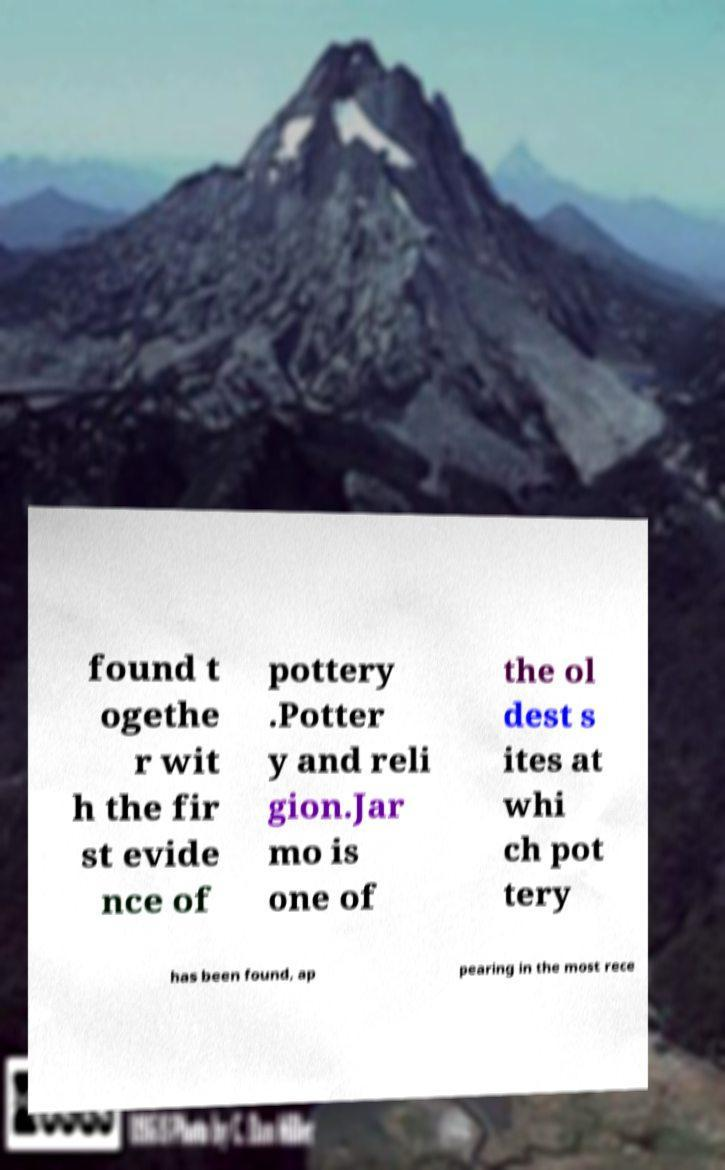What messages or text are displayed in this image? I need them in a readable, typed format. found t ogethe r wit h the fir st evide nce of pottery .Potter y and reli gion.Jar mo is one of the ol dest s ites at whi ch pot tery has been found, ap pearing in the most rece 